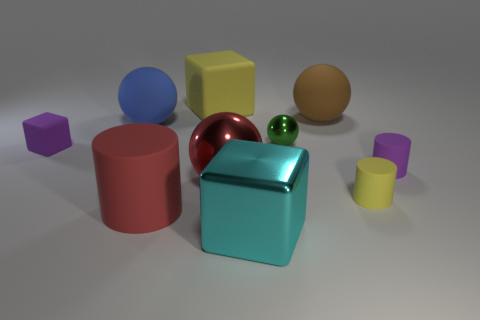What is the color of the cylinder that is the same size as the blue object?
Ensure brevity in your answer.  Red. There is a yellow rubber object right of the brown ball; is there a big yellow object that is behind it?
Make the answer very short. Yes. There is a yellow object behind the blue thing; what is it made of?
Make the answer very short. Rubber. Do the tiny cylinder to the left of the purple cylinder and the tiny purple thing to the right of the purple cube have the same material?
Provide a succinct answer. Yes. Are there the same number of metallic objects that are to the left of the small purple matte block and large brown matte spheres that are left of the tiny sphere?
Your answer should be compact. Yes. How many red cylinders are made of the same material as the brown object?
Give a very brief answer. 1. What is the shape of the rubber thing that is the same color as the big rubber cube?
Offer a very short reply. Cylinder. What is the size of the rubber cylinder that is in front of the yellow object on the right side of the large brown ball?
Your answer should be very brief. Large. There is a brown matte thing that is right of the small sphere; does it have the same shape as the yellow matte thing that is behind the brown thing?
Your response must be concise. No. Are there the same number of large cylinders that are behind the large yellow cube and yellow matte things?
Provide a succinct answer. No. 